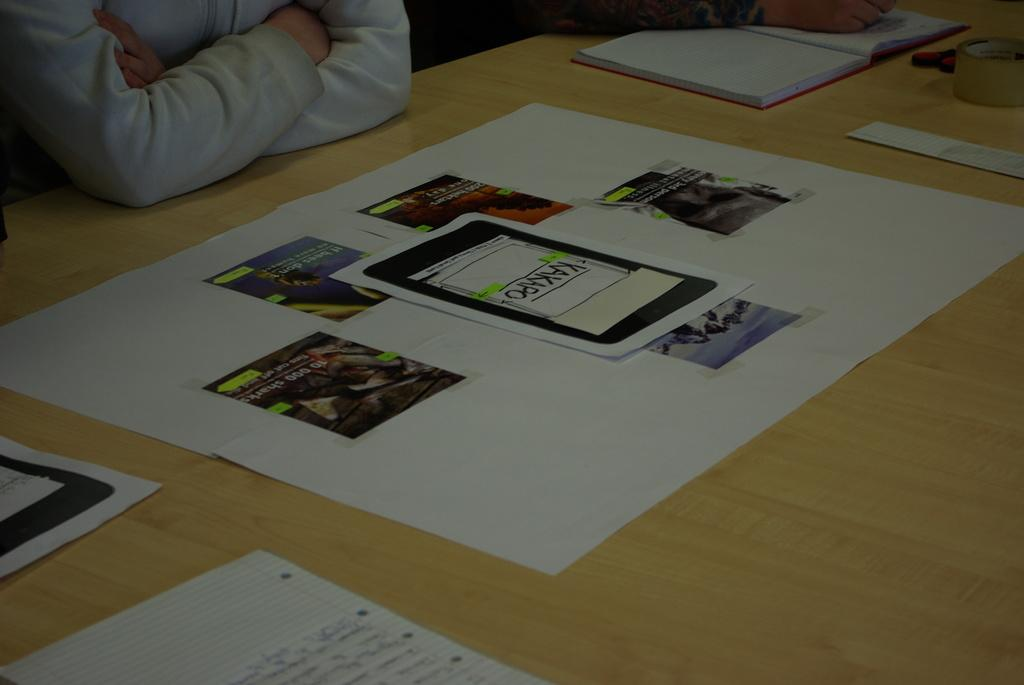What is on the table in the image? There are grouped papers, a book, tape, and scissors on the table. How are the papers arranged on the table? The papers are grouped together. Is there anything connecting the papers? Yes, the papers are stuck to another paper. What might be used to cut the papers? Scissors are on the table, which could be used to cut the papers. What type of sheet is being used to fly the plane in the image? There is no plane or sheet present in the image; it only features grouped papers, a book, tape, and scissors on a table. 